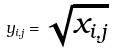<formula> <loc_0><loc_0><loc_500><loc_500>y _ { i , j } = \sqrt { x _ { i , j } }</formula> 